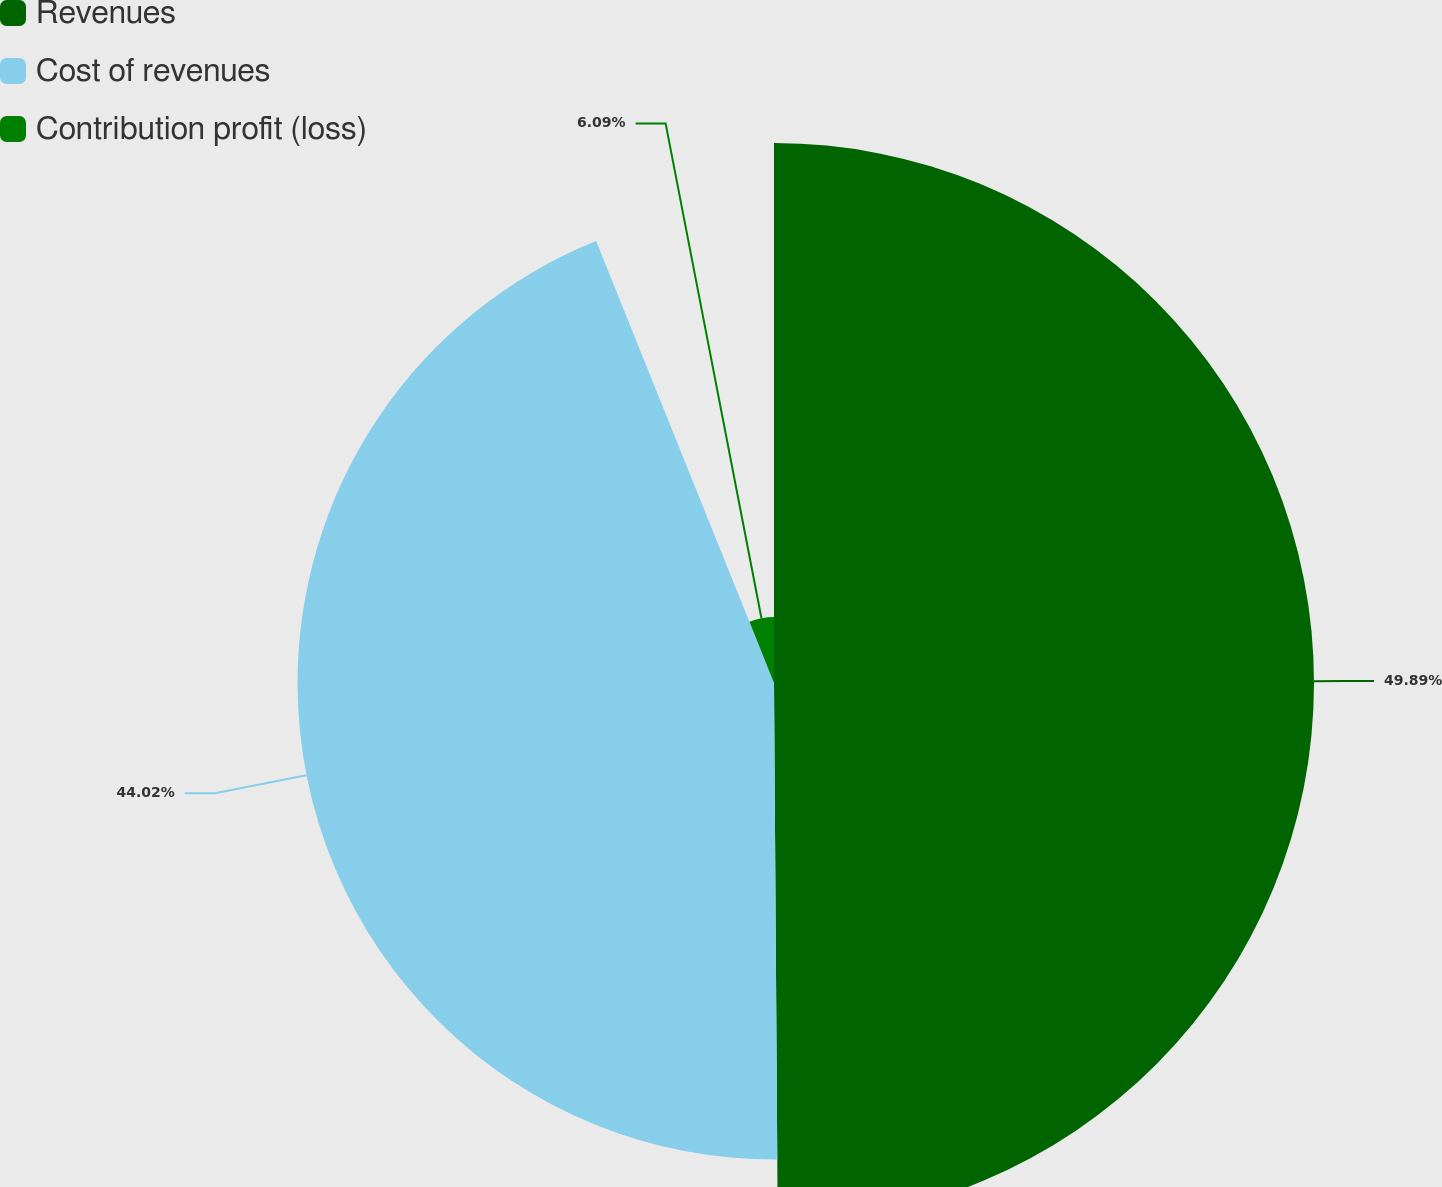Convert chart to OTSL. <chart><loc_0><loc_0><loc_500><loc_500><pie_chart><fcel>Revenues<fcel>Cost of revenues<fcel>Contribution profit (loss)<nl><fcel>49.89%<fcel>44.02%<fcel>6.09%<nl></chart> 